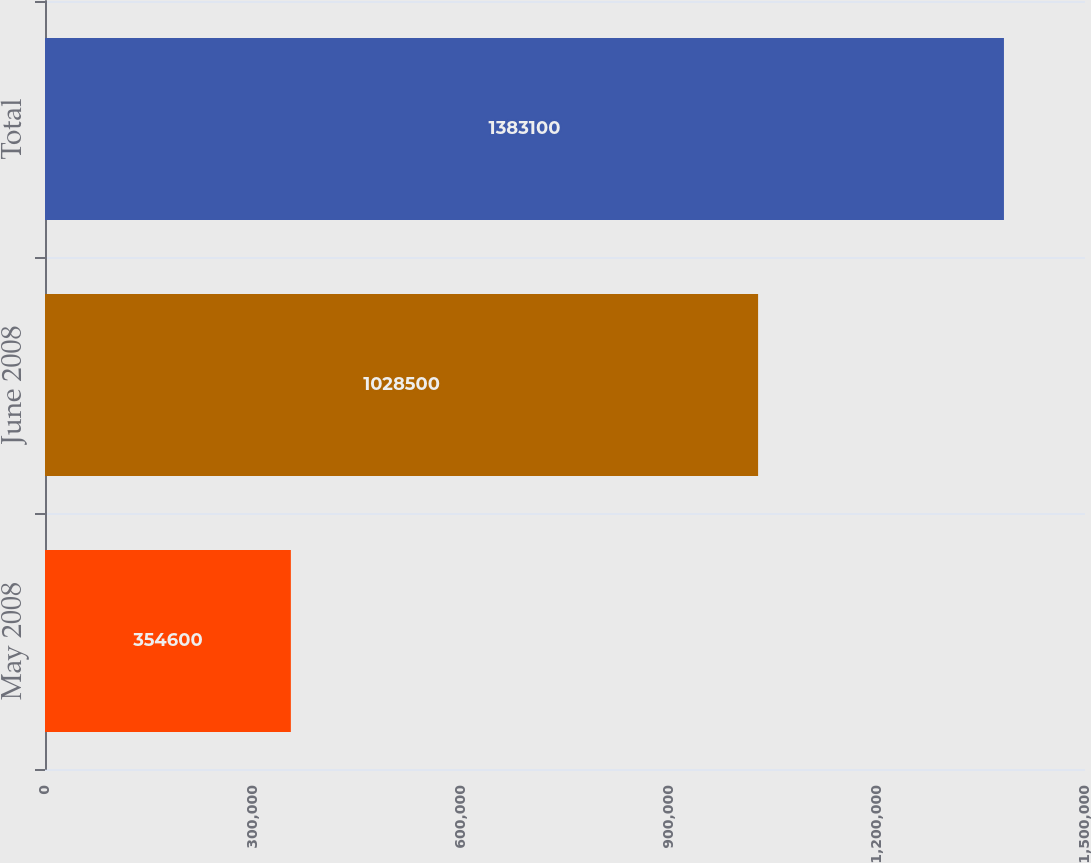Convert chart to OTSL. <chart><loc_0><loc_0><loc_500><loc_500><bar_chart><fcel>May 2008<fcel>June 2008<fcel>Total<nl><fcel>354600<fcel>1.0285e+06<fcel>1.3831e+06<nl></chart> 